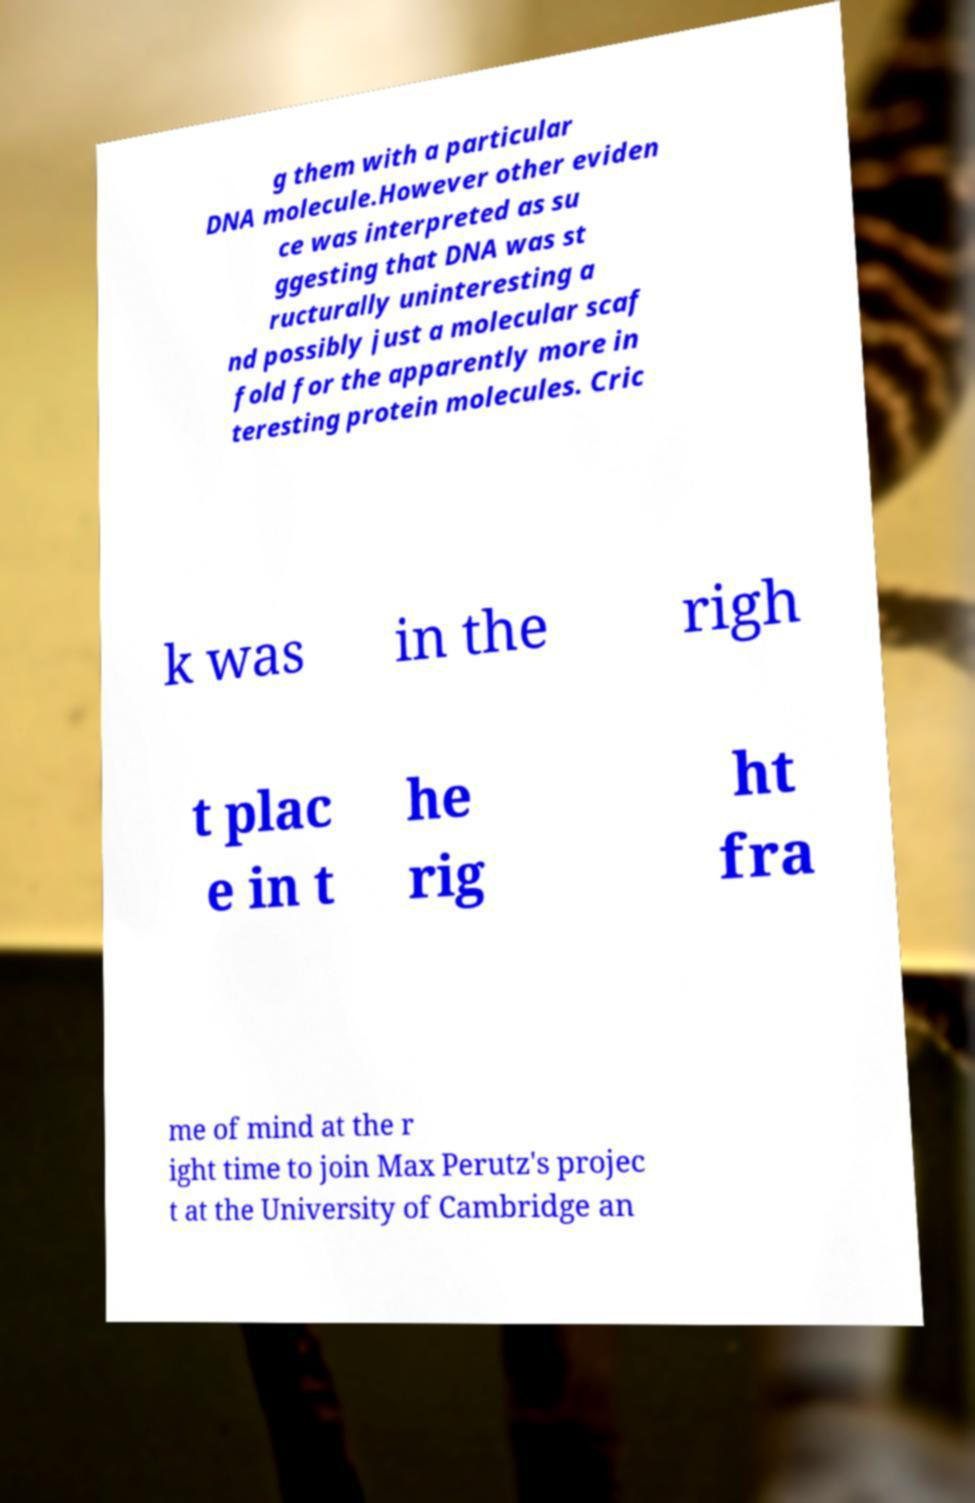What messages or text are displayed in this image? I need them in a readable, typed format. g them with a particular DNA molecule.However other eviden ce was interpreted as su ggesting that DNA was st ructurally uninteresting a nd possibly just a molecular scaf fold for the apparently more in teresting protein molecules. Cric k was in the righ t plac e in t he rig ht fra me of mind at the r ight time to join Max Perutz's projec t at the University of Cambridge an 